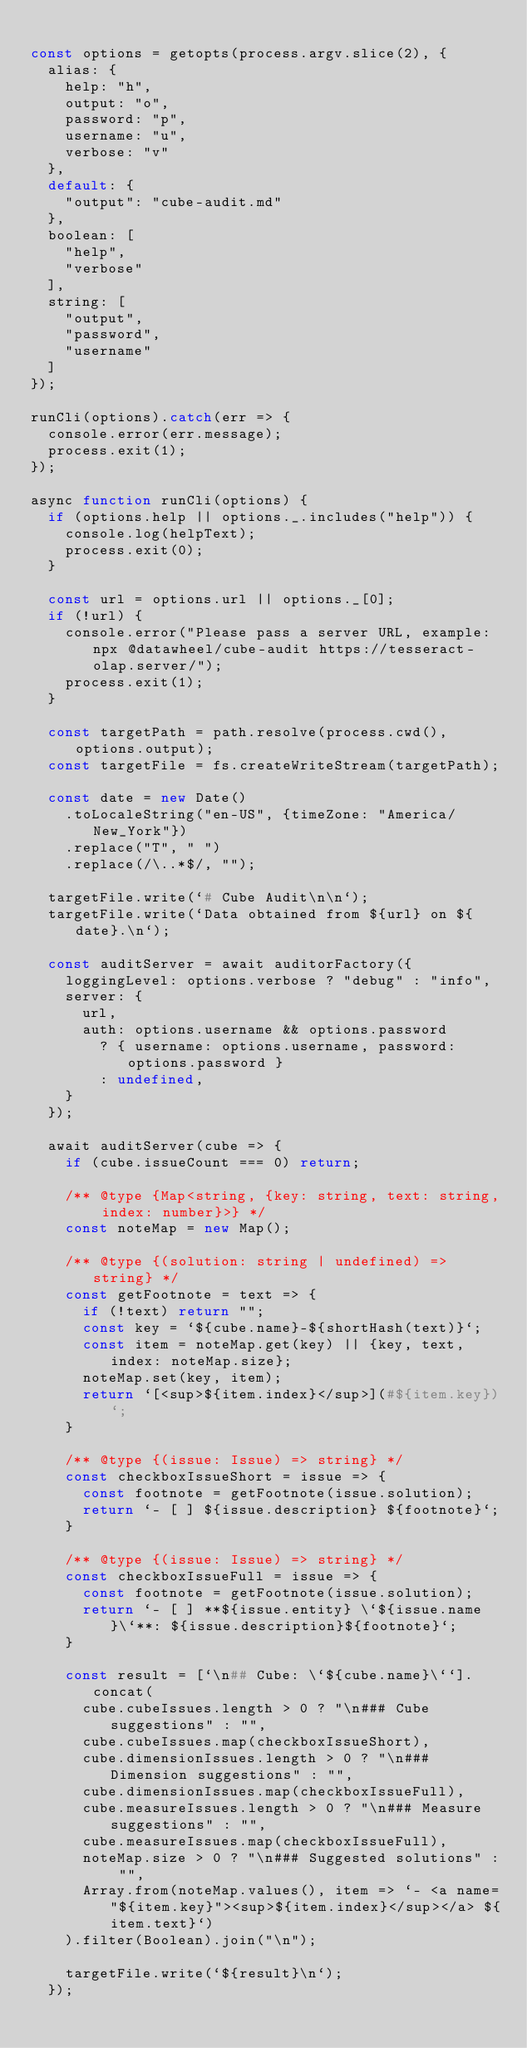Convert code to text. <code><loc_0><loc_0><loc_500><loc_500><_JavaScript_>
const options = getopts(process.argv.slice(2), {
  alias: {
    help: "h",
    output: "o",
    password: "p",
    username: "u",
    verbose: "v"
  },
  default: {
    "output": "cube-audit.md"
  },
  boolean: [
    "help",
    "verbose"
  ],
  string: [
    "output",
    "password",
    "username"
  ]
});

runCli(options).catch(err => {
  console.error(err.message);
  process.exit(1);
});

async function runCli(options) {
  if (options.help || options._.includes("help")) {
    console.log(helpText);
    process.exit(0);
  }

  const url = options.url || options._[0];
  if (!url) {
    console.error("Please pass a server URL, example: npx @datawheel/cube-audit https://tesseract-olap.server/");
    process.exit(1);
  }

  const targetPath = path.resolve(process.cwd(), options.output);
  const targetFile = fs.createWriteStream(targetPath);

  const date = new Date()
    .toLocaleString("en-US", {timeZone: "America/New_York"})
    .replace("T", " ")
    .replace(/\..*$/, "");

  targetFile.write(`# Cube Audit\n\n`);
  targetFile.write(`Data obtained from ${url} on ${date}.\n`);

  const auditServer = await auditorFactory({
    loggingLevel: options.verbose ? "debug" : "info",
    server: {
      url,
      auth: options.username && options.password
        ? { username: options.username, password: options.password }
        : undefined,
    }
  });

  await auditServer(cube => {
    if (cube.issueCount === 0) return;

    /** @type {Map<string, {key: string, text: string, index: number}>} */
    const noteMap = new Map();

    /** @type {(solution: string | undefined) => string} */
    const getFootnote = text => {
      if (!text) return "";
      const key = `${cube.name}-${shortHash(text)}`;
      const item = noteMap.get(key) || {key, text, index: noteMap.size};
      noteMap.set(key, item);
      return `[<sup>${item.index}</sup>](#${item.key})`;
    }

    /** @type {(issue: Issue) => string} */
    const checkboxIssueShort = issue => {
      const footnote = getFootnote(issue.solution);
      return `- [ ] ${issue.description} ${footnote}`;
    }

    /** @type {(issue: Issue) => string} */
    const checkboxIssueFull = issue => {
      const footnote = getFootnote(issue.solution);
      return `- [ ] **${issue.entity} \`${issue.name}\`**: ${issue.description}${footnote}`;
    }

    const result = [`\n## Cube: \`${cube.name}\``].concat(
      cube.cubeIssues.length > 0 ? "\n### Cube suggestions" : "",
      cube.cubeIssues.map(checkboxIssueShort),
      cube.dimensionIssues.length > 0 ? "\n### Dimension suggestions" : "",
      cube.dimensionIssues.map(checkboxIssueFull),
      cube.measureIssues.length > 0 ? "\n### Measure suggestions" : "",
      cube.measureIssues.map(checkboxIssueFull),
      noteMap.size > 0 ? "\n### Suggested solutions" : "",
      Array.from(noteMap.values(), item => `- <a name="${item.key}"><sup>${item.index}</sup></a> ${item.text}`)
    ).filter(Boolean).join("\n");

    targetFile.write(`${result}\n`);
  });
</code> 